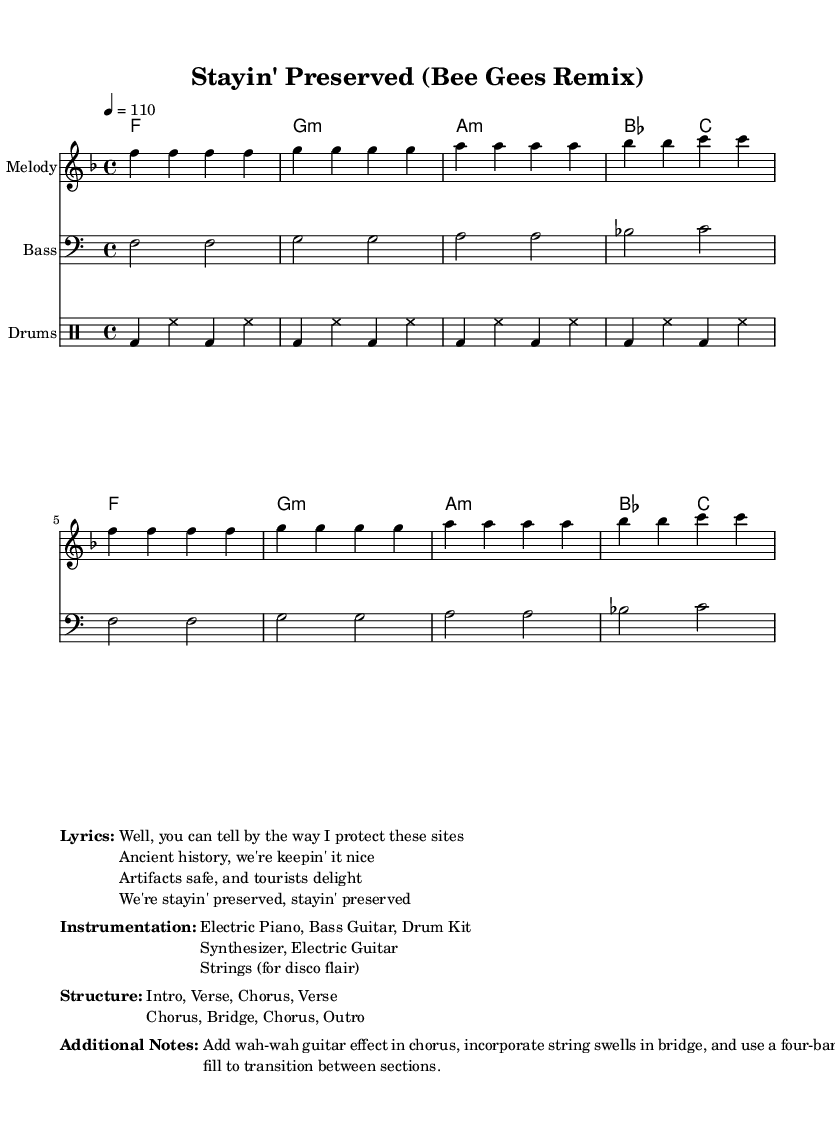What is the key signature of this music? The key signature is indicated at the beginning of the music sheet after the clef. It shows one flat, which means this piece is in F major.
Answer: F major What is the time signature of this music? The time signature is also shown at the beginning of the music, with a '4/4' indication. This means each measure has four beats, and the quarter note gets one beat.
Answer: 4/4 What is the tempo of this piece? The tempo is specified above the staff as '4 = 110', indicating the speed of the piece in beats per minute. This means there are 110 beats per minute.
Answer: 110 How many sections are there in the structure? The structure section lists the form of the music. It indicates that there are six distinct sections: Intro, Verse, Chorus, Verse, Chorus, Bridge, Chorus, and Outro. Therefore, the total is eight sections.
Answer: 8 What instruments are included in this arrangement? The instruments are listed in the "Instrumentation" section, specifically mentioning Electric Piano, Bass Guitar, Drum Kit, Synthesizer, Electric Guitar, and Strings.
Answer: Electric Piano, Bass Guitar, Drum Kit, Synthesizer, Electric Guitar, Strings What type of musical effect is suggested in the chorus? The additional notes mention adding a "wah-wah guitar effect" in the chorus, a stylistic choice often found in disco music to enhance the sound.
Answer: Wah-wah guitar effect 